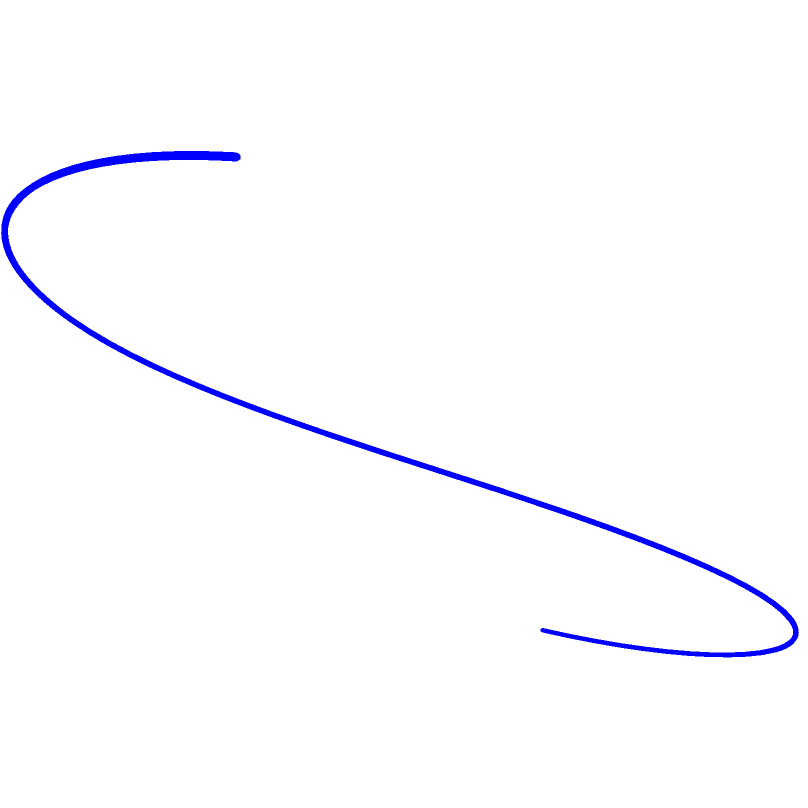Given a 2D motion path for a stunt double's movement (shown in red), you need to transform it into a 3D trajectory for a CGI character (shown in blue). The 2D path is defined by the function $f(x) = \sin(\frac{\pi x}{2})$ for $0 \leq x \leq 4$. To create the 3D trajectory, you apply a vertical transformation defined by $g(x) = \frac{x^2}{8}$. What is the parametric equation of the resulting 3D trajectory in terms of $t$, where $0 \leq t \leq 4$? To solve this problem, we'll follow these steps:

1. Identify the 2D motion path:
   $x = t$
   $y = f(t) = \sin(\frac{\pi t}{2})$
   where $0 \leq t \leq 4$

2. Apply the vertical transformation:
   $z = g(t) = \frac{t^2}{8}$

3. Combine the equations to form the 3D parametric equation:
   $x = t$
   $y = \sin(\frac{\pi t}{2})$
   $z = \frac{t^2}{8}$
   where $0 \leq t \leq 4$

4. Express the parametric equation in vector form:
   $\vec{r}(t) = \left\langle t, \sin(\frac{\pi t}{2}), \frac{t^2}{8} \right\rangle$, $0 \leq t \leq 4$

This parametric equation describes the 3D trajectory of the CGI character based on the given 2D motion path and vertical transformation.
Answer: $\vec{r}(t) = \left\langle t, \sin(\frac{\pi t}{2}), \frac{t^2}{8} \right\rangle$, $0 \leq t \leq 4$ 